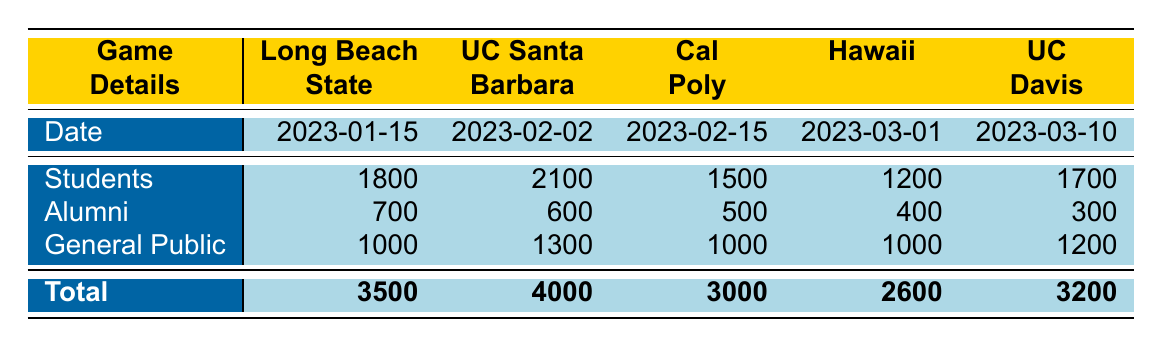What was the total attendance at the game against UC Santa Barbara? From the table, under the UC Santa Barbara column, the total attendance value is listed as 4000.
Answer: 4000 How many students attended the game against Long Beach State? Looking at the Long Beach State row, the number of students is recorded as 1800.
Answer: 1800 What is the average attendance of all five games? The total attendance for the five games is 3500 + 4000 + 3000 + 2600 + 3200 = 19800. Dividing by the number of games (5), the average attendance is 19800 / 5 = 3960.
Answer: 3960 Did more alumni attend the game against UC Davis than the game against Hawaii? The number of alumni for UC Davis is 300, and for Hawaii, it is 400. Since 300 is less than 400, the answer is no.
Answer: No What was the total number of general public attendees across all games? The total number of general public attendees is calculated as follows: 1000 (Long Beach) + 1300 (UC Santa Barbara) + 1000 (Cal Poly) + 1000 (Hawaii) + 1200 (UC Davis) = 5300.
Answer: 5300 Which game had the highest number of students in attendance? Checking the student attendance for each game, the highest number is for UC Santa Barbara, with 2100 students attending.
Answer: UC Santa Barbara What was the difference in total attendance between the game against Cal Poly and the game against Hawaii? The attendance for Cal Poly is 3000, and for Hawaii, it is 2600. The difference is calculated as 3000 - 2600 = 400.
Answer: 400 Did the total attendance for any game exceed 4000? The total attendance for each game is compared with 4000. Only the game against UC Santa Barbara had an attendance of exactly 4000; no game exceeded this.
Answer: No 